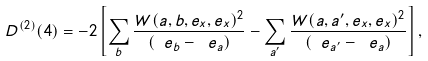<formula> <loc_0><loc_0><loc_500><loc_500>\ D ^ { ( 2 ) } ( 4 ) = - 2 \left [ \sum _ { b } \frac { W ( a , b , e _ { x } , e _ { x } ) ^ { 2 } } { ( \ e _ { b } - \ e _ { a } ) } - \sum _ { a ^ { \prime } } \frac { W ( a , a ^ { \prime } , e _ { x } , e _ { x } ) ^ { 2 } } { ( \ e _ { a ^ { \prime } } - \ e _ { a } ) } \right ] ,</formula> 